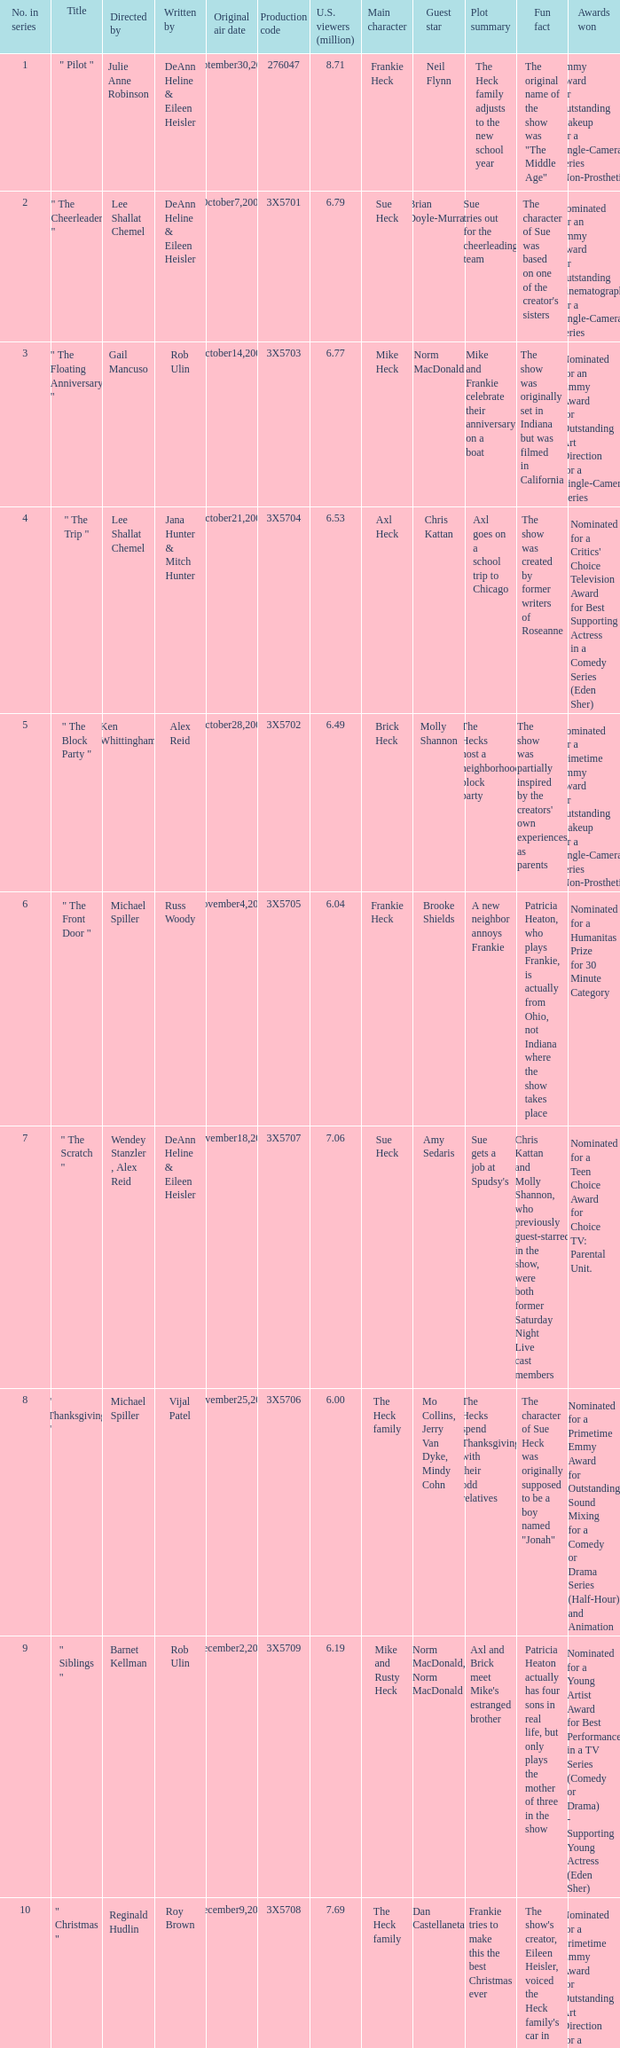How many directors got 6.79 million U.S. viewers from their episodes? 1.0. 